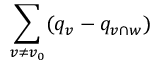Convert formula to latex. <formula><loc_0><loc_0><loc_500><loc_500>\sum _ { v \neq v _ { 0 } } ( q _ { v } - q _ { v \cap w } )</formula> 